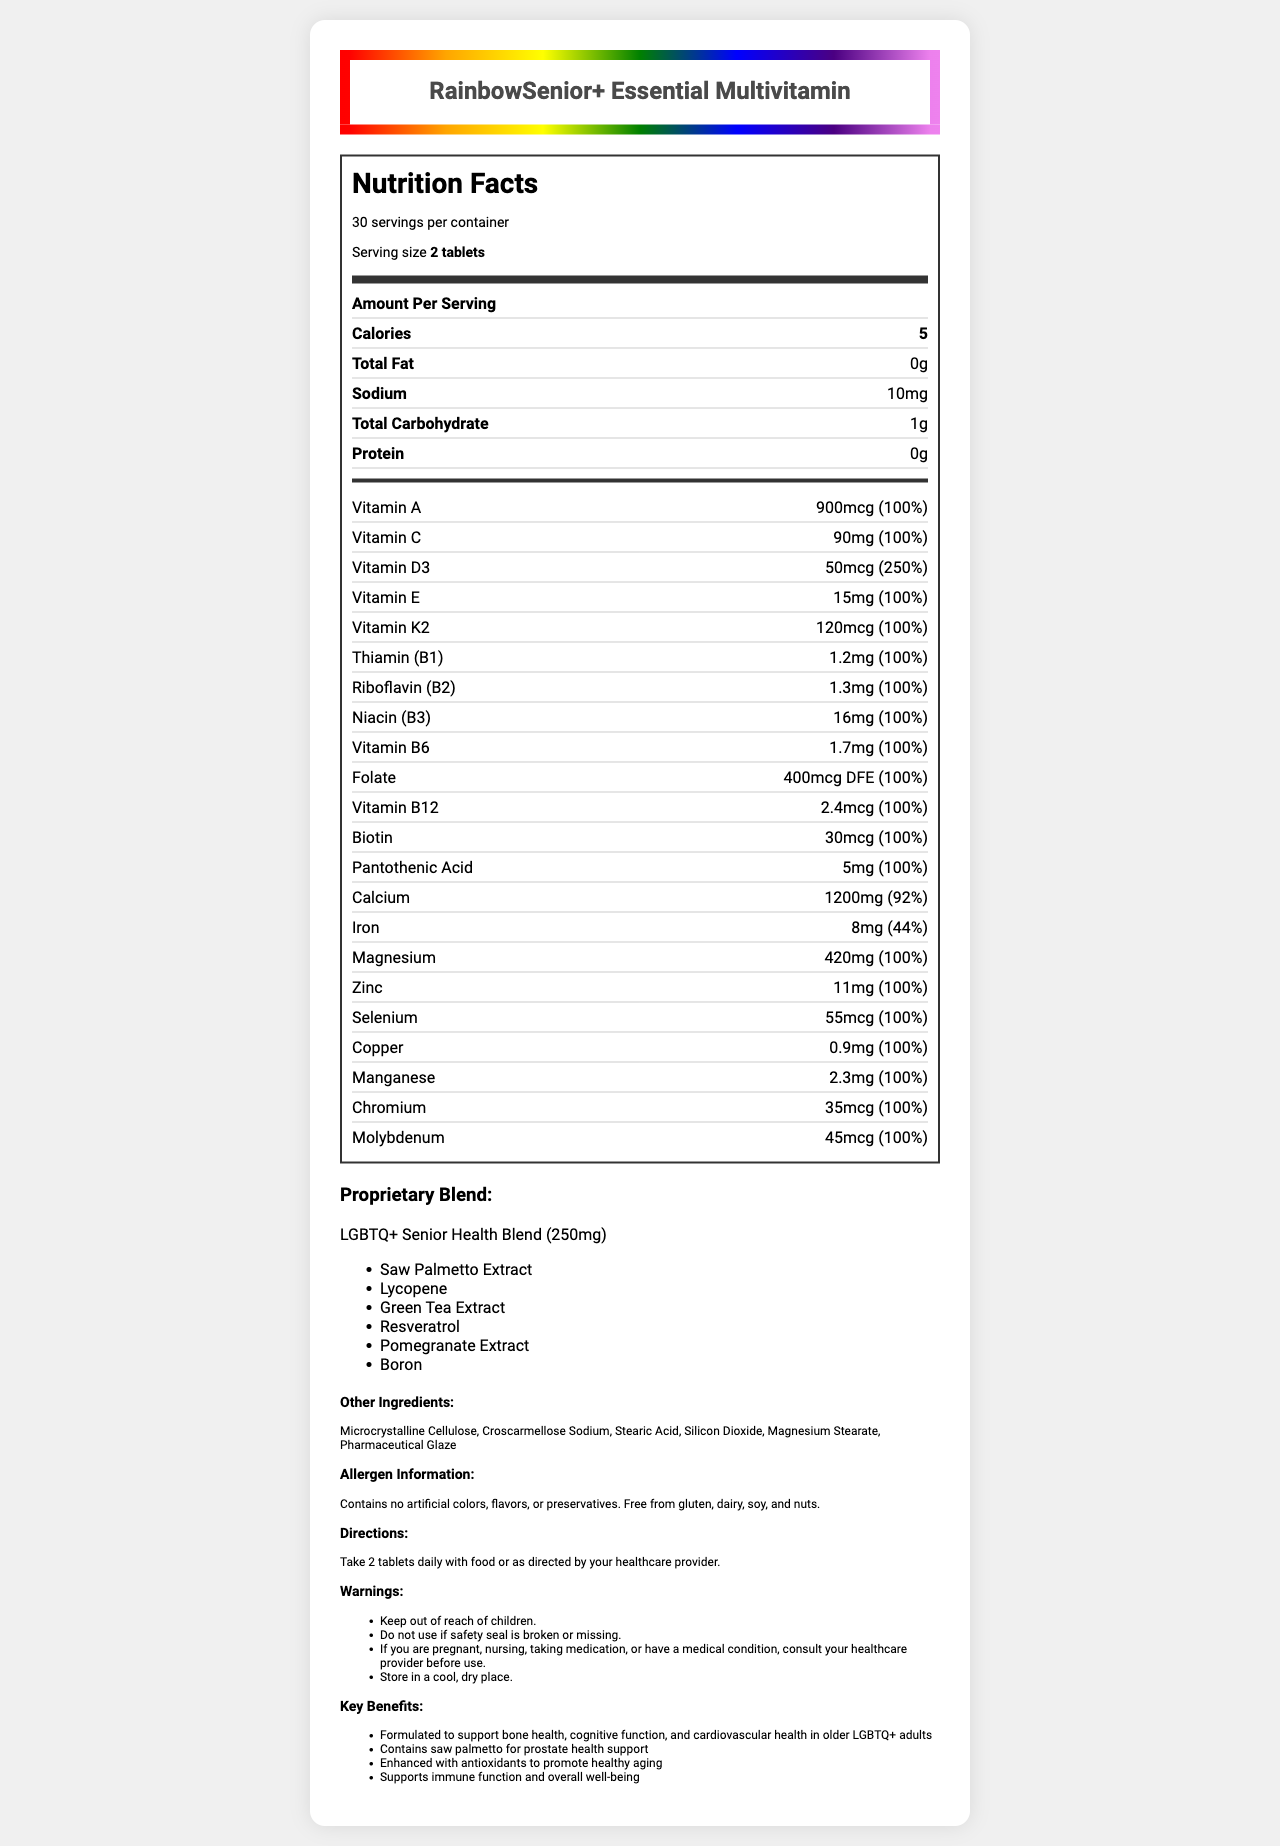what is the product name? The product name is displayed prominently at the top of the document within the rainbow-bordered section.
Answer: RainbowSenior+ Essential Multivitamin How many calories are in one serving? The document lists the number of calories per serving as 5 in the "Amount Per Serving" section.
Answer: 5 What is the serving size for RainbowSenior+ Essential Multivitamin? The serving size is specified as "2 tablets" in the serving information section.
Answer: 2 tablets How much sodium is there per serving? The sodium content per serving is indicated as 10mg in the nutrient row for sodium.
Answer: 10mg How much Vitamin D3 is in one serving? Vitamin D3 is listed in the vitamins and minerals section with an amount of 50mcg.
Answer: 50mcg Are there any preservatives in RainbowSenior+ Essential Multivitamin? The allergen information states that the product contains no artificial colors, flavors, or preservatives.
Answer: No What is the daily value percentage of calcium in one serving? A. 44% B. 92% C. 100% D. 250% The daily value percentage for calcium is listed as 92% in the vitamins and minerals section.
Answer: B. 92% Which of these ingredients is included in the proprietary blend? 
I. Saw Palmetto Extract
II. Lycopene
III. Green Tea Extract
A. Only I
B. I and II
C. II and III
D. I, II, and III All three ingredients, Saw Palmetto Extract, Lycopene, and Green Tea Extract, are listed as part of the proprietary blend.
Answer: D. I, II, and III Should children consume this product? One of the warnings explicitly states to keep the multivitamin out of reach of children.
Answer: No Is the product free from gluten? The allergen information mentions that the product is free from gluten.
Answer: Yes Summarize the main health benefits claimed by the product. These are the key benefits listed under the "Key Benefits" section of the document.
Answer: Formulated to support bone health, cognitive function, and cardiovascular health in older LGBTQ+ adults, contains saw palmetto for prostate health support, enhanced with antioxidants to promote healthy aging, supports immune function and overall well-being. Does the product contain information on how it supports recent surgery recovery? The document does not provide any information on whether the product supports recovery from recent surgery.
Answer: Cannot be determined 